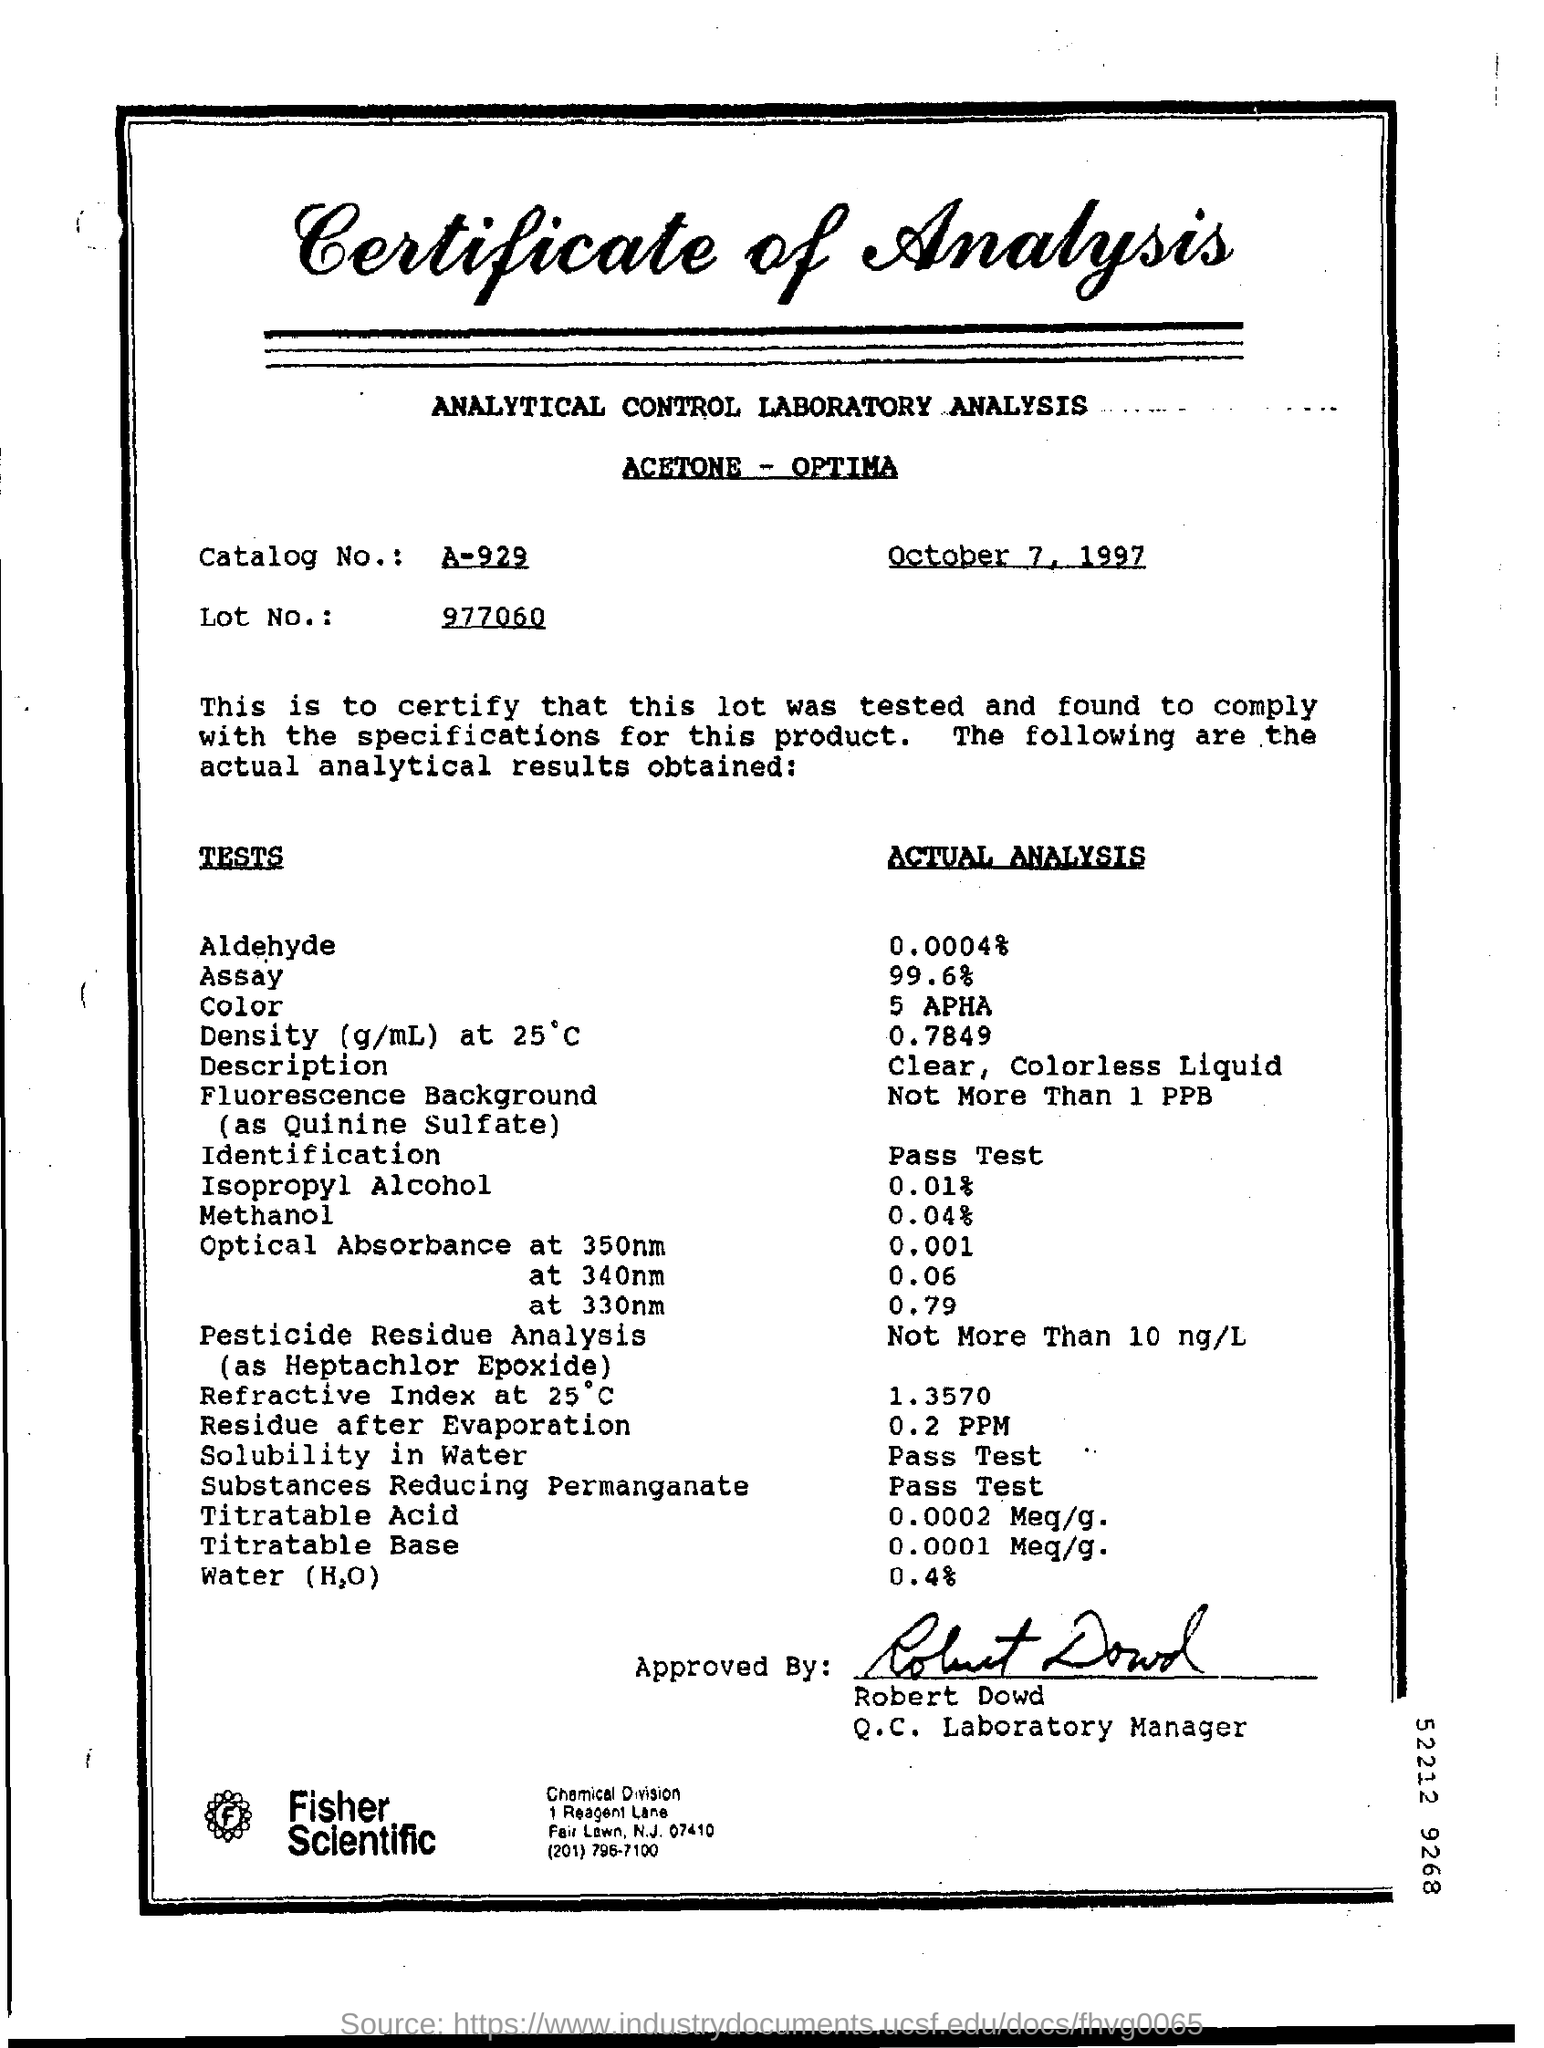What is the date mentioned?
Your response must be concise. October 7, 1997. What is the lot no.?
Ensure brevity in your answer.  977060. 